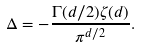<formula> <loc_0><loc_0><loc_500><loc_500>\Delta = - \frac { \Gamma ( d / 2 ) \zeta ( d ) } { \pi ^ { d / 2 } } .</formula> 